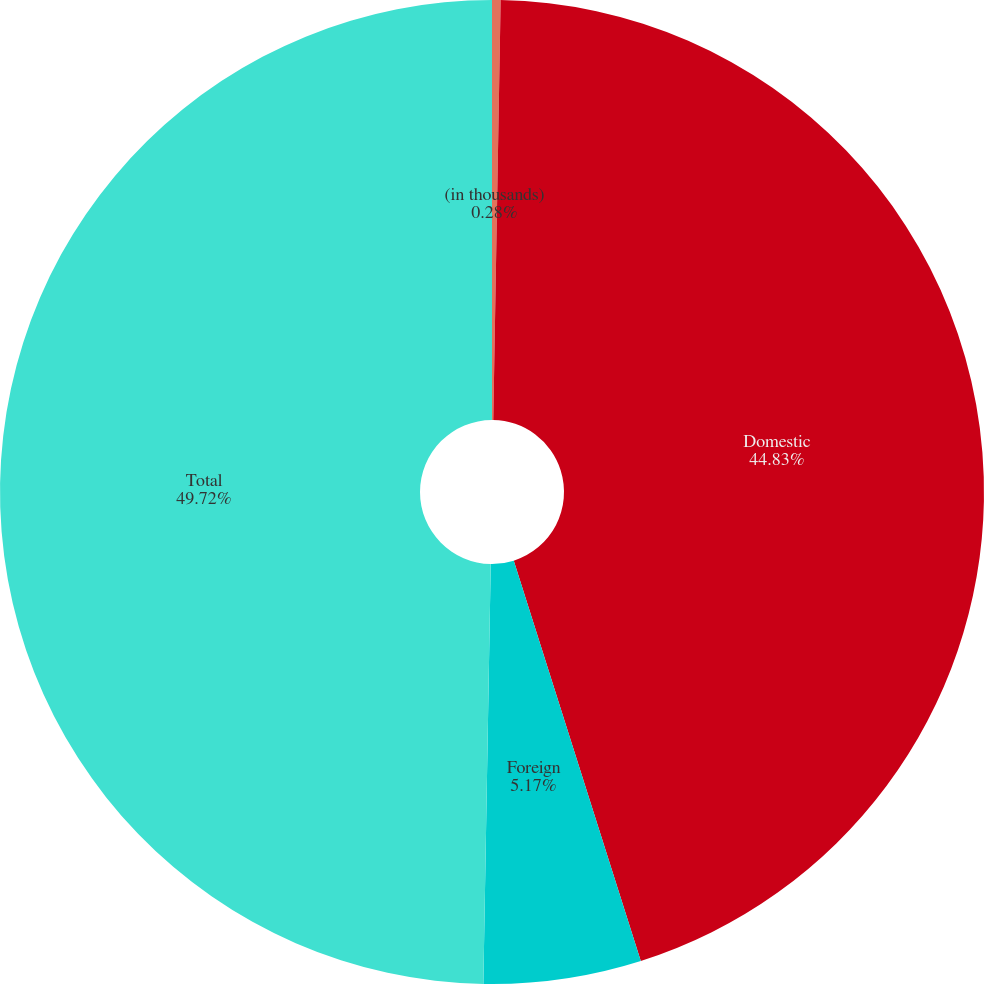Convert chart. <chart><loc_0><loc_0><loc_500><loc_500><pie_chart><fcel>(in thousands)<fcel>Domestic<fcel>Foreign<fcel>Total<nl><fcel>0.28%<fcel>44.83%<fcel>5.17%<fcel>49.72%<nl></chart> 